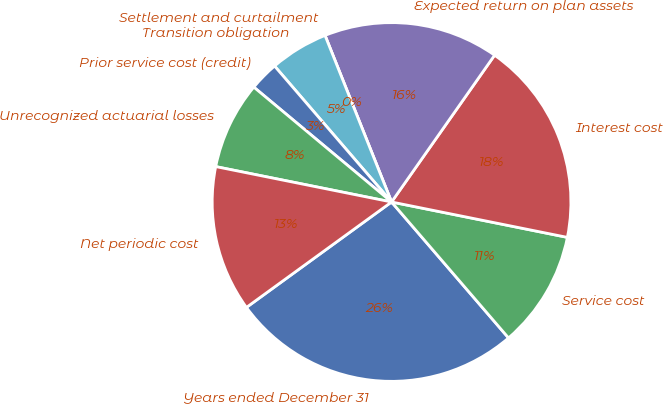Convert chart. <chart><loc_0><loc_0><loc_500><loc_500><pie_chart><fcel>Years ended December 31<fcel>Service cost<fcel>Interest cost<fcel>Expected return on plan assets<fcel>Settlement and curtailment<fcel>Transition obligation<fcel>Prior service cost (credit)<fcel>Unrecognized actuarial losses<fcel>Net periodic cost<nl><fcel>26.31%<fcel>10.53%<fcel>18.42%<fcel>15.79%<fcel>0.0%<fcel>5.26%<fcel>2.63%<fcel>7.9%<fcel>13.16%<nl></chart> 